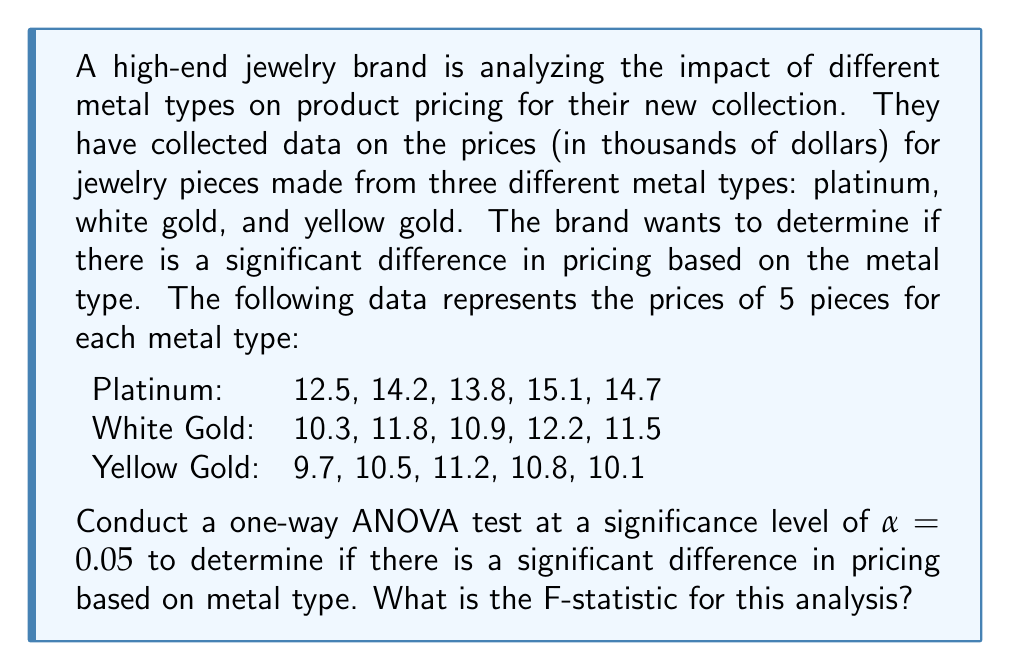Solve this math problem. To conduct a one-way ANOVA test and calculate the F-statistic, we'll follow these steps:

1. Calculate the sum of squares between groups (SSB)
2. Calculate the sum of squares within groups (SSW)
3. Calculate the total sum of squares (SST)
4. Determine the degrees of freedom
5. Calculate the mean squares
6. Compute the F-statistic

Step 1: Calculate SSB

First, we need to calculate the grand mean and the means for each group:

Grand mean: $\bar{X} = \frac{(12.5 + 14.2 + ... + 10.1)}{15} = 12.22$

Group means:
Platinum: $\bar{X}_1 = 14.06$
White Gold: $\bar{X}_2 = 11.34$
Yellow Gold: $\bar{X}_3 = 10.46$

Now we can calculate SSB:

$$SSB = \sum_{i=1}^{k} n_i(\bar{X}_i - \bar{X})^2$$

Where $k$ is the number of groups and $n_i$ is the number of observations in each group.

$$SSB = 5(14.06 - 12.22)^2 + 5(11.34 - 12.22)^2 + 5(10.46 - 12.22)^2 = 40.4453$$

Step 2: Calculate SSW

$$SSW = \sum_{i=1}^{k} \sum_{j=1}^{n_i} (X_{ij} - \bar{X}_i)^2$$

Platinum: $(12.5 - 14.06)^2 + (14.2 - 14.06)^2 + ... + (14.7 - 14.06)^2 = 3.4924$
White Gold: $(10.3 - 11.34)^2 + (11.8 - 11.34)^2 + ... + (11.5 - 11.34)^2 = 2.4024$
Yellow Gold: $(9.7 - 10.46)^2 + (10.5 - 10.46)^2 + ... + (10.1 - 10.46)^2 = 1.4924$

$$SSW = 3.4924 + 2.4024 + 1.4924 = 7.3872$$

Step 3: Calculate SST

$$SST = SSB + SSW = 40.4453 + 7.3872 = 47.8325$$

Step 4: Determine degrees of freedom

Between groups: $df_B = k - 1 = 3 - 1 = 2$
Within groups: $df_W = N - k = 15 - 3 = 12$
Total: $df_T = N - 1 = 15 - 1 = 14$

Step 5: Calculate mean squares

$$MSB = \frac{SSB}{df_B} = \frac{40.4453}{2} = 20.22265$$
$$MSW = \frac{SSW}{df_W} = \frac{7.3872}{12} = 0.6156$$

Step 6: Compute the F-statistic

$$F = \frac{MSB}{MSW} = \frac{20.22265}{0.6156} = 32.85$$
Answer: The F-statistic for this analysis is 32.85. 